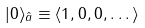Convert formula to latex. <formula><loc_0><loc_0><loc_500><loc_500>| 0 \rangle _ { \hat { a } } \equiv \langle 1 , 0 , 0 , \dots \rangle</formula> 